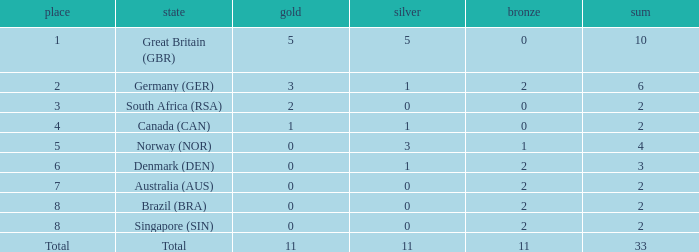What is bronze when the rank is 3 and the total is more than 2? None. 